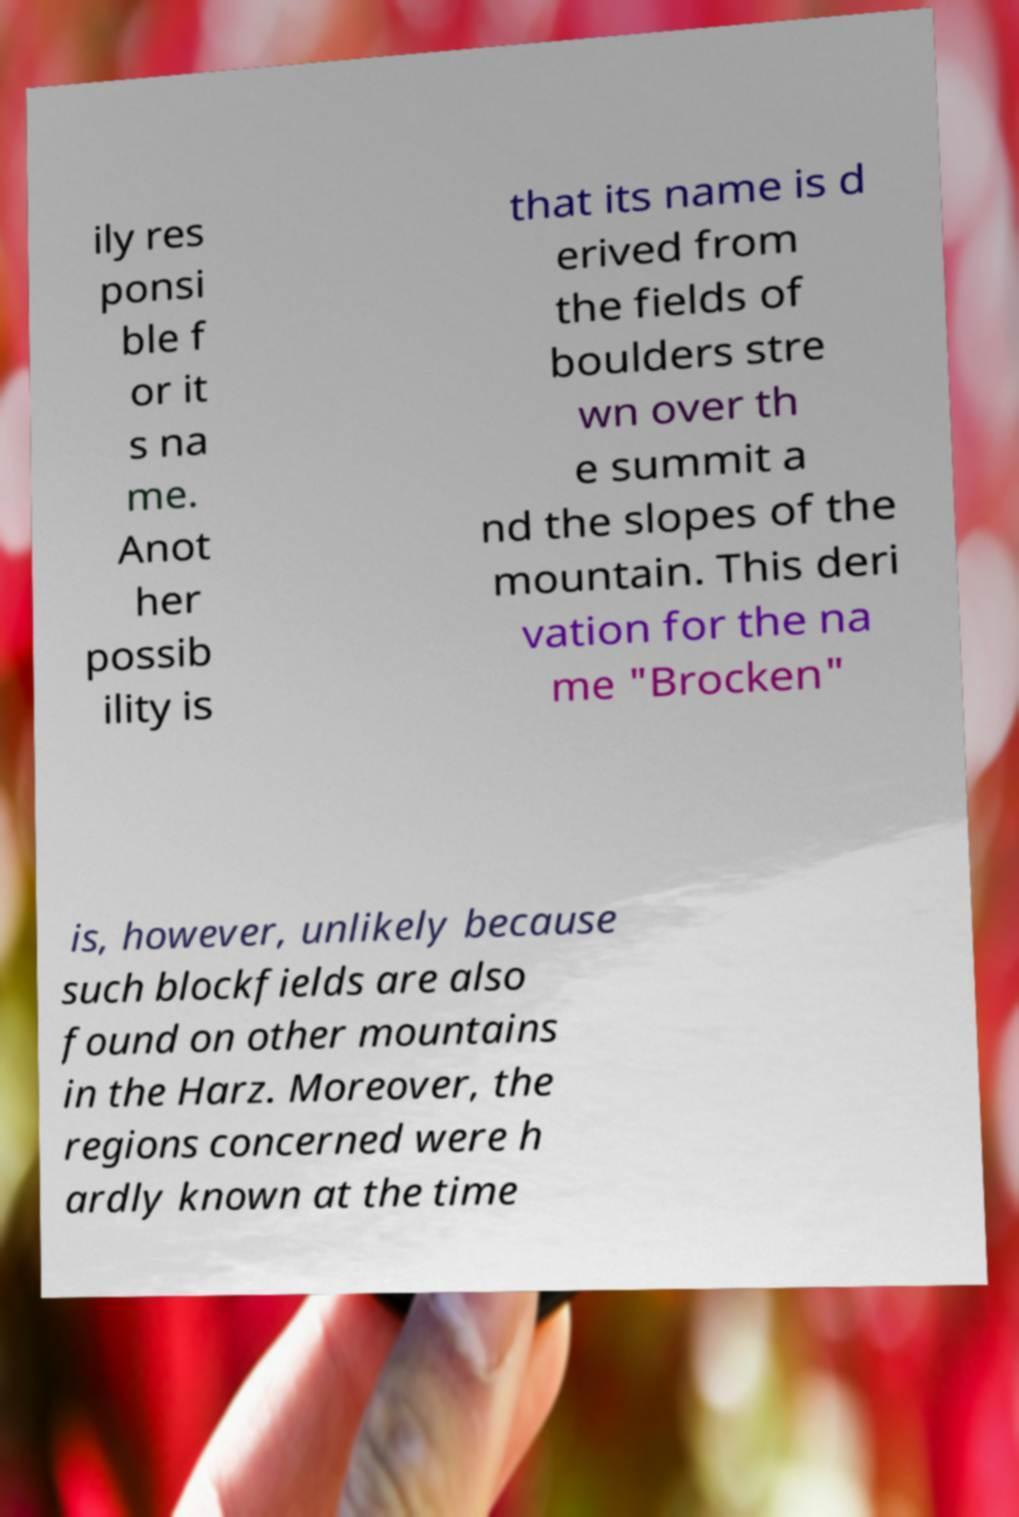Can you accurately transcribe the text from the provided image for me? ily res ponsi ble f or it s na me. Anot her possib ility is that its name is d erived from the fields of boulders stre wn over th e summit a nd the slopes of the mountain. This deri vation for the na me "Brocken" is, however, unlikely because such blockfields are also found on other mountains in the Harz. Moreover, the regions concerned were h ardly known at the time 